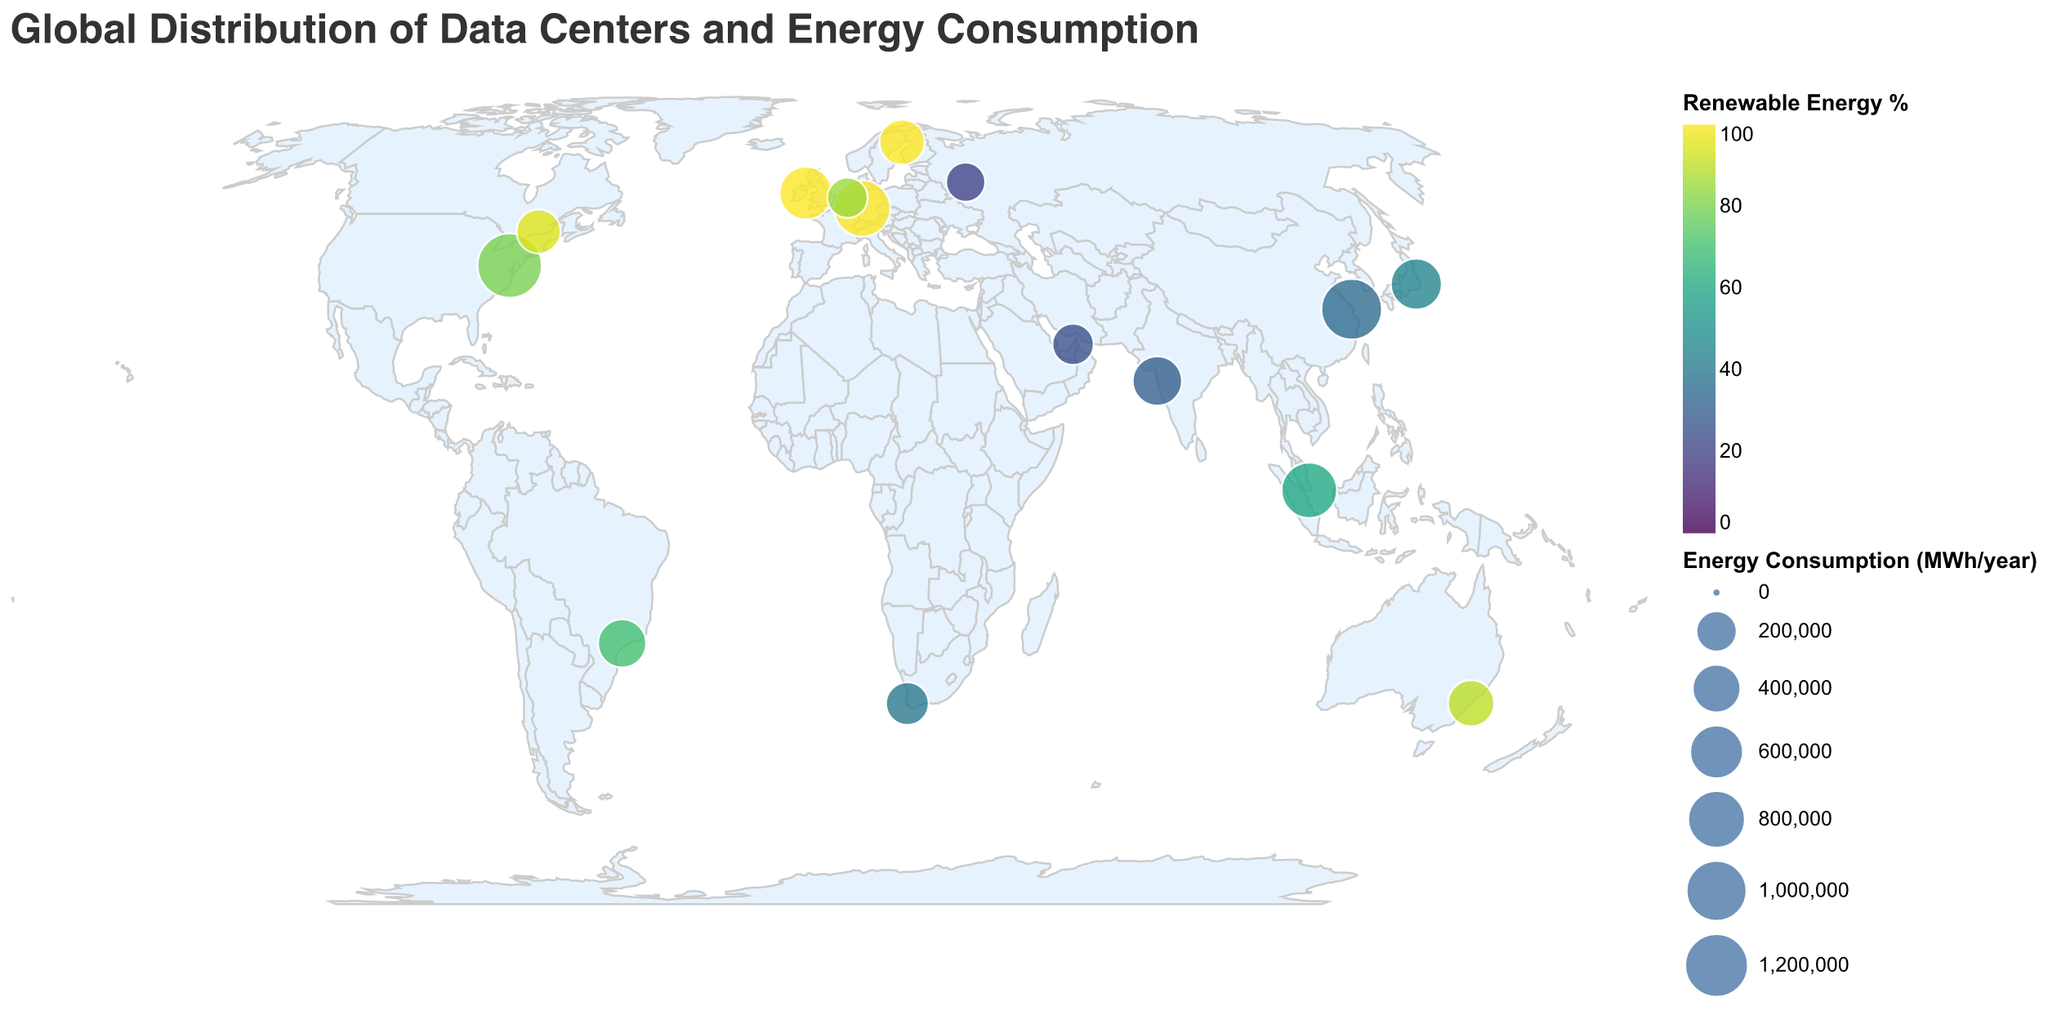Which country has the data center with the highest energy consumption? The highest energy consumption is represented by the largest circle on the map, which is in the United States
Answer: United States Which data center has the lowest percentage of renewable energy usage? The smallest percentage of renewable energy usage is indicated by the color on the scale. The darkest color represents the lowest renewable energy percentage, which is in Russia.
Answer: Rostelecom Data Center Which data centers use 100% renewable energy? The color scale helps us identify data centers using 100% renewable energy. The brightest color indicates 100% renewable usage. These data centers are in Germany, Ireland, and Sweden.
Answer: Google Cloud Frankfurt, Facebook Clonee, Facebook Luleå What is the total energy consumption of the data centers in Asia? Asia includes data centers in China, Singapore, Japan, and India. Summing their energy consumption gives us 980000 + 680000 + 480000 + 420000 = 2560000 MWh/year.
Answer: 2560000 MWh/year Which continent has the most data centers shown in the figure? Counting the data centers by continent, North America has the most with data centers in the United States and Canada.
Answer: North America How does the renewable energy usage of Amazon Web Services US East compare to Microsoft Azure Singapore? By checking the color scale, Amazon Web Services US East has a renewable energy percentage of 80, while Microsoft Azure Singapore has 60.
Answer: Amazon Web Services US East has higher renewable energy usage Rank the top three data centers by energy consumption. The largest circles on the map represent the top three energy-consuming data centers, which are Amazon Web Services US East, Alibaba Cloud Shanghai, and Google Cloud Frankfurt.
Answer: Amazon Web Services US East, Alibaba Cloud Shanghai, Google Cloud Frankfurt Identify the data center using the highest percentage of renewable energy in Europe. Based on the color scale, the highest renewable energy usage in Europe is represented by Google Cloud Frankfurt and Facebook Clonee, both using 100% renewable energy.
Answer: Google Cloud Frankfurt, Facebook Clonee Which data center in the Americas consumes the least energy? By observing the smaller circles in the Americas, the OVHcloud Montreal in Canada has the smallest circle, indicating the least energy consumption.
Answer: OVHcloud Montreal Compare the energy consumption of data centers in Sydney and Dubai. The size of the circles indicates energy consumption: Sydney (NextDC S2) has a larger circle with 320000 MWh/year compared to Dubai (Khazna Data Center) with 200000 MWh/year.
Answer: Sydney's data center consumes more energy 